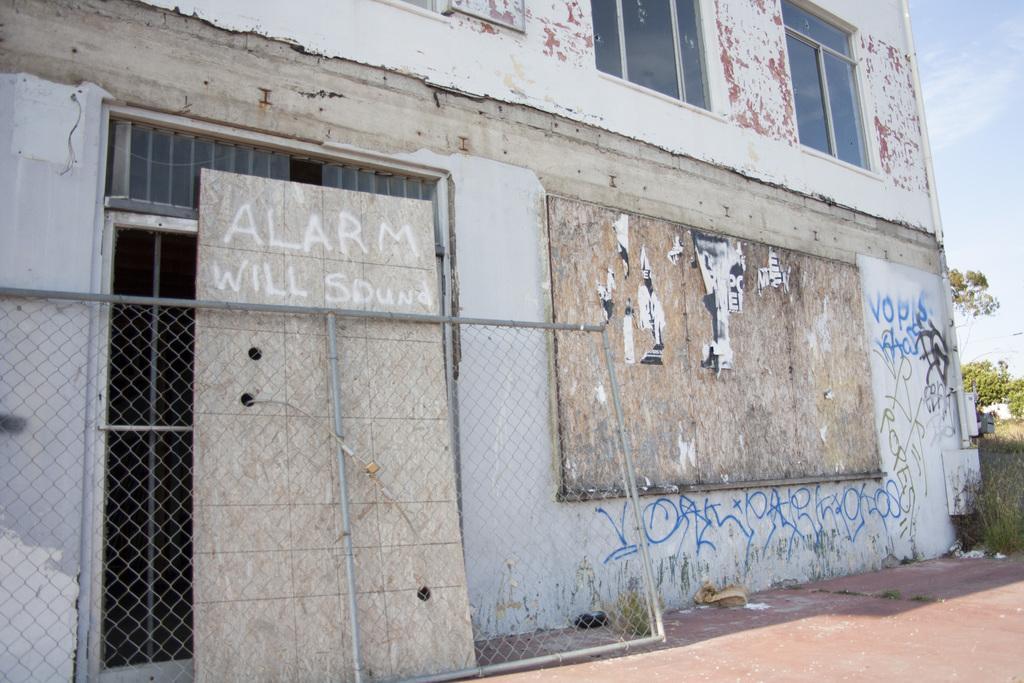Can you describe this image briefly? In this image I can see the mesh. In the background, I can see a building with some text written on it. I can also see the grass, trees and clouds in the sky. 